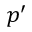Convert formula to latex. <formula><loc_0><loc_0><loc_500><loc_500>p ^ { \prime }</formula> 